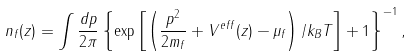Convert formula to latex. <formula><loc_0><loc_0><loc_500><loc_500>n _ { f } ( z ) = \int \frac { d p } { 2 \pi } \left \{ \exp \left [ \left ( \frac { p ^ { 2 } } { 2 m _ { f } } + V ^ { e f f } ( z ) - \mu _ { f } \right ) / k _ { B } T \right ] + 1 \right \} ^ { - 1 } ,</formula> 